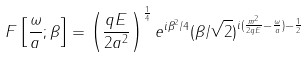Convert formula to latex. <formula><loc_0><loc_0><loc_500><loc_500>F \left [ \frac { \omega } { a } ; \beta \right ] = \left ( \frac { q E } { 2 a ^ { 2 } } \right ) ^ { \frac { 1 } { 4 } } e ^ { i \beta ^ { 2 } / 4 } ( \beta / \sqrt { 2 } ) ^ { i ( \frac { m ^ { 2 } } { 2 q E } - \frac { \omega } { a } ) - \frac { 1 } { 2 } }</formula> 